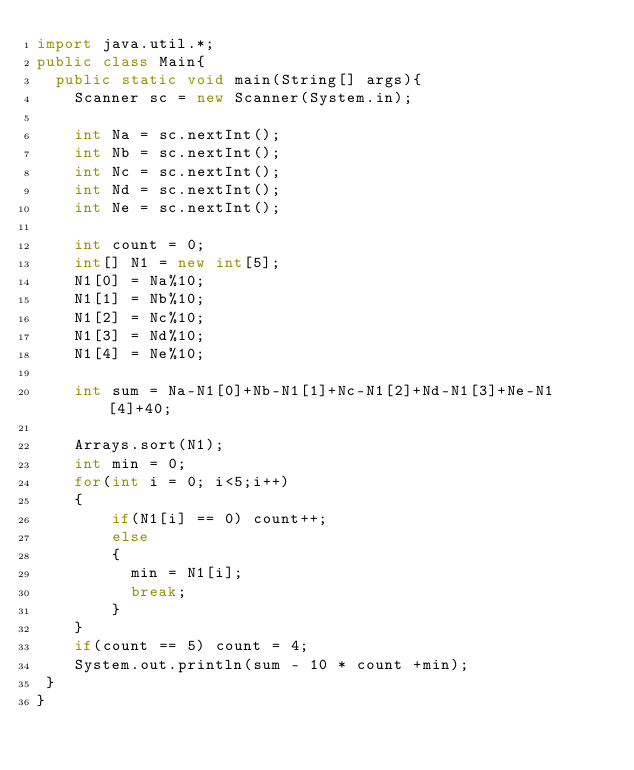Convert code to text. <code><loc_0><loc_0><loc_500><loc_500><_Java_>import java.util.*;
public class Main{
  public static void main(String[] args){
   	Scanner sc = new Scanner(System.in);
 
    int Na = sc.nextInt();
    int Nb = sc.nextInt();
    int Nc = sc.nextInt();
    int Nd = sc.nextInt();
    int Ne = sc.nextInt();
    
    int count = 0;
    int[] N1 = new int[5];
    N1[0] = Na%10;
    N1[1] = Nb%10;
    N1[2] = Nc%10;
    N1[3] = Nd%10;
    N1[4] = Ne%10;
    
    int sum = Na-N1[0]+Nb-N1[1]+Nc-N1[2]+Nd-N1[3]+Ne-N1[4]+40;
    
    Arrays.sort(N1);
    int min = 0;
    for(int i = 0; i<5;i++)
    {
    	if(N1[i] == 0) count++;
      	else 
        {
          min = N1[i];
          break;
        }
    }
    if(count == 5) count = 4;
   	System.out.println(sum - 10 * count +min);
 }
}</code> 